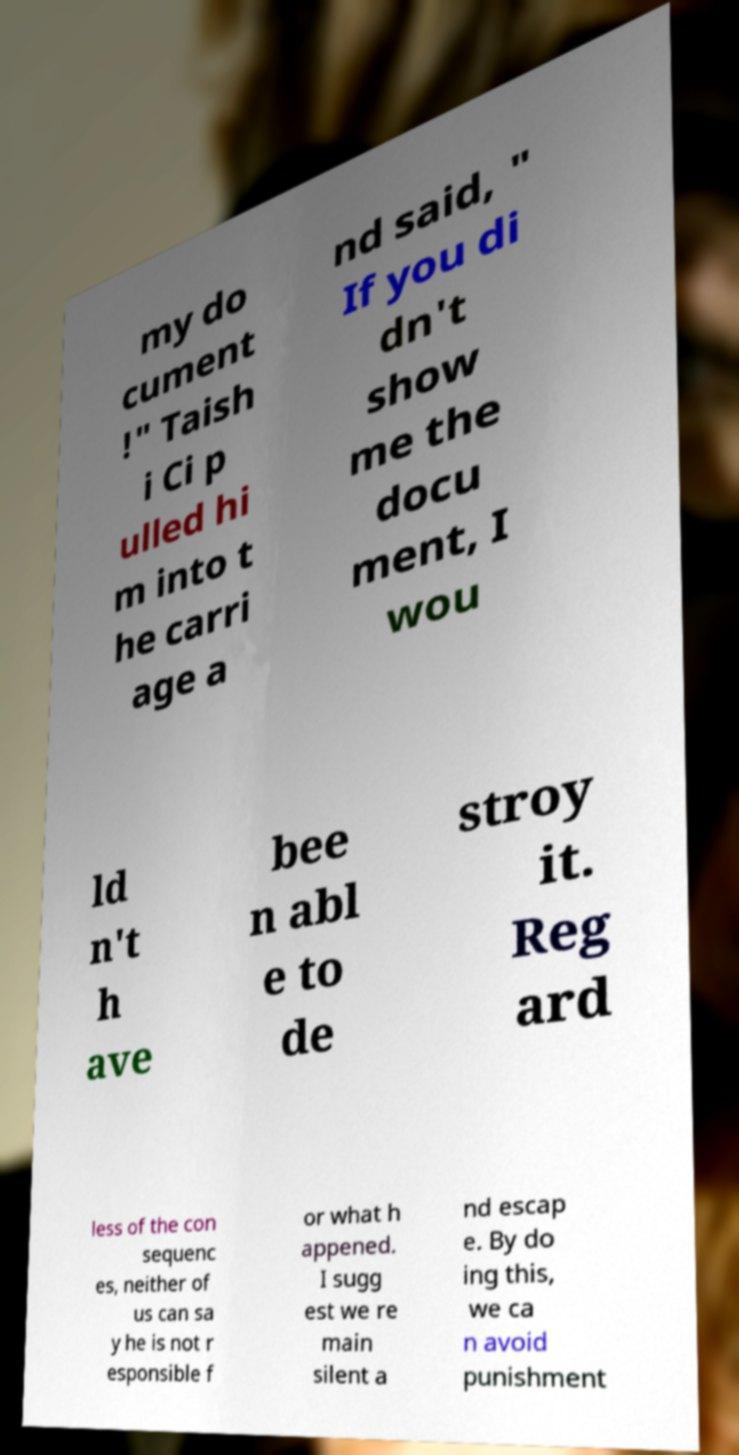Can you accurately transcribe the text from the provided image for me? my do cument !" Taish i Ci p ulled hi m into t he carri age a nd said, " If you di dn't show me the docu ment, I wou ld n't h ave bee n abl e to de stroy it. Reg ard less of the con sequenc es, neither of us can sa y he is not r esponsible f or what h appened. I sugg est we re main silent a nd escap e. By do ing this, we ca n avoid punishment 